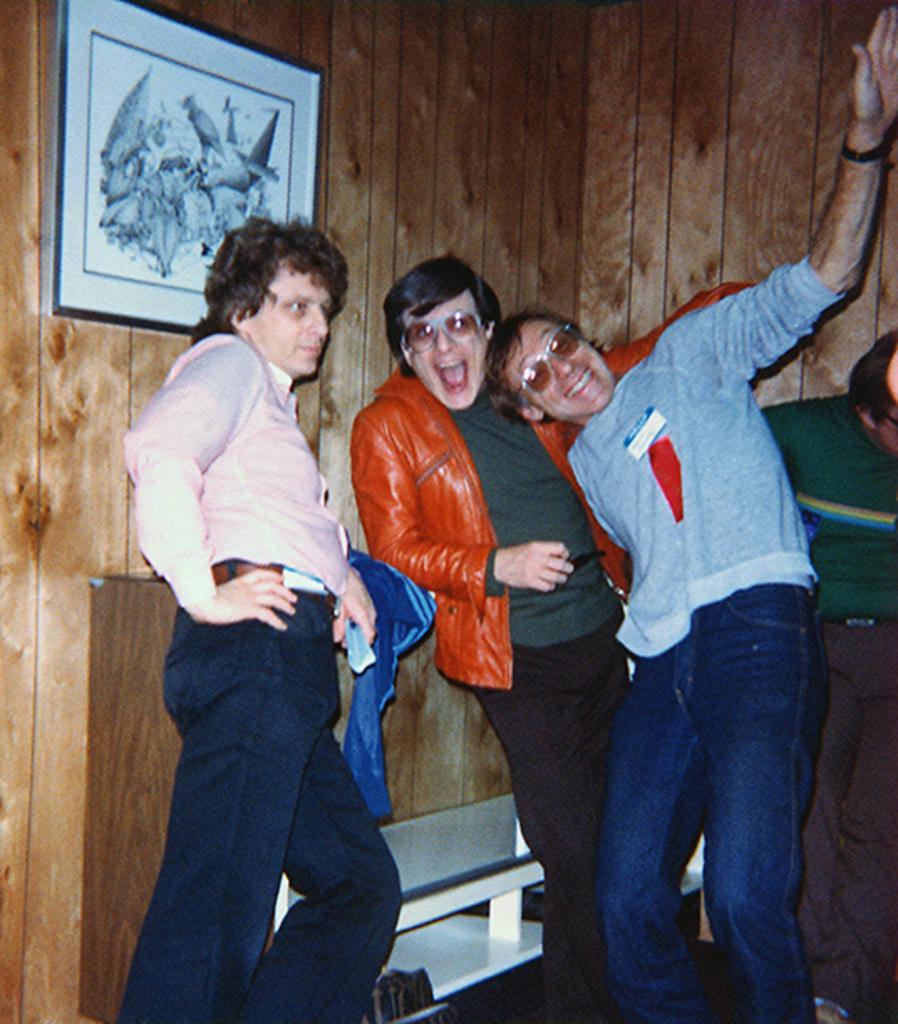How would you summarize this image in a sentence or two? In this picture there are four persons standing and there is a photo frame attached to the wooden wall in the left top corner. 